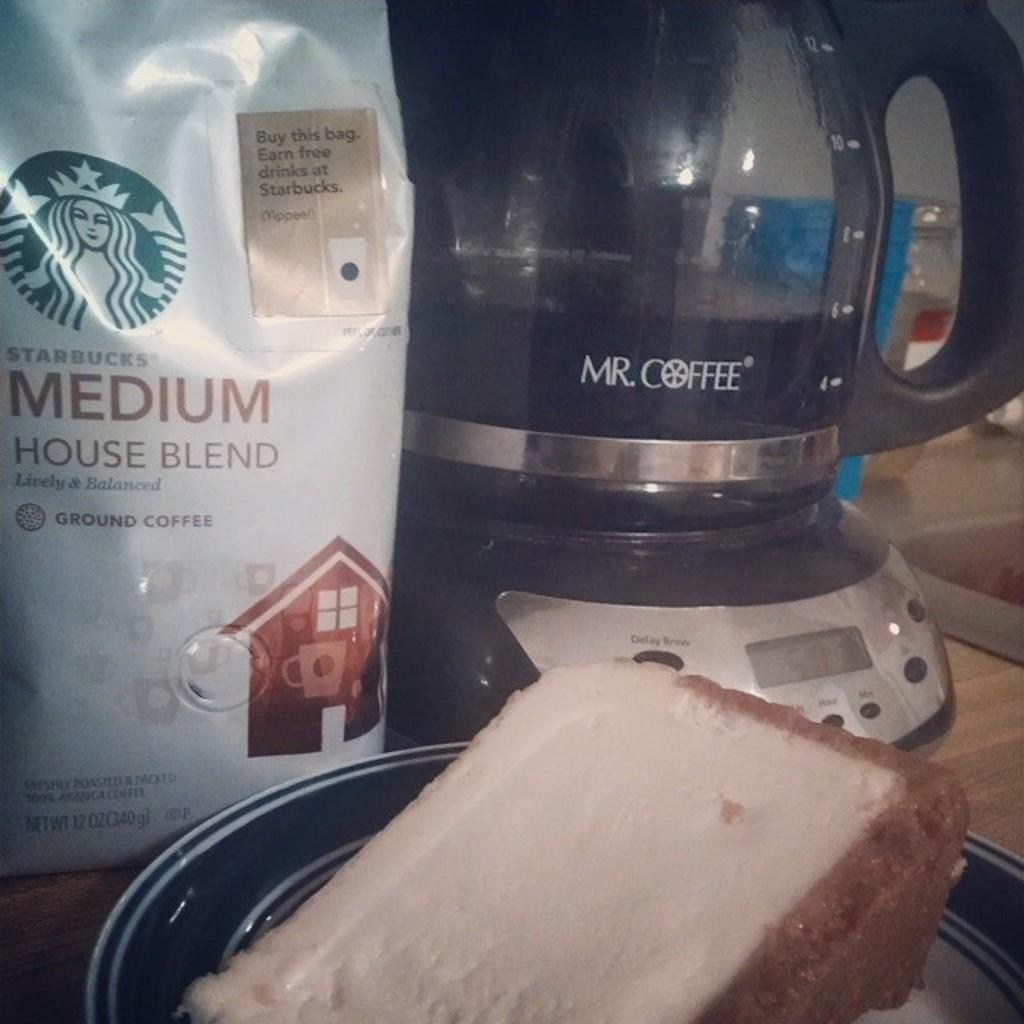Provide a one-sentence caption for the provided image. some coffee and a coffee maker by Mr Coffee on the table with a piece of cake. 